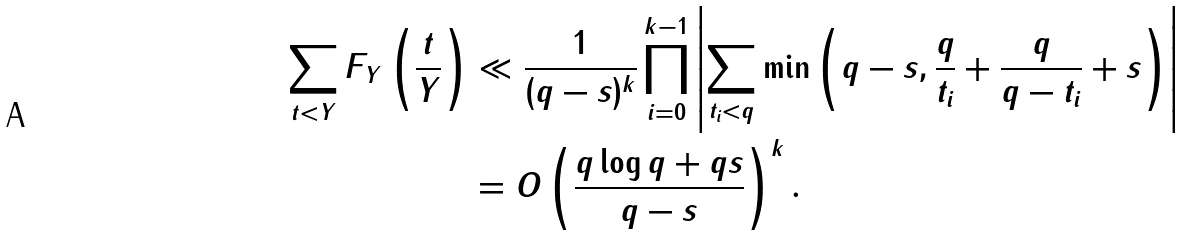Convert formula to latex. <formula><loc_0><loc_0><loc_500><loc_500>\sum _ { t < Y } F _ { Y } \left ( \frac { t } { Y } \right ) & \ll \frac { 1 } { ( q - s ) ^ { k } } \prod _ { i = 0 } ^ { k - 1 } \left | \sum _ { t _ { i } < q } \min \left ( q - s , \frac { q } { t _ { i } } + \frac { q } { q - t _ { i } } + s \right ) \right | \\ & = O \left ( \frac { q \log { q } + q s } { q - s } \right ) ^ { k } .</formula> 